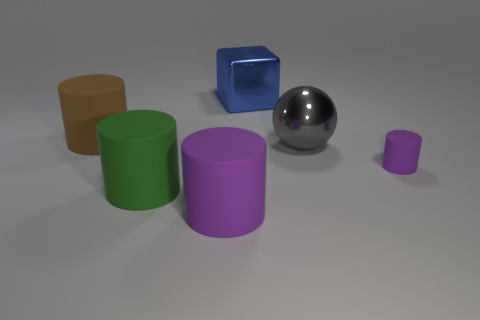Subtract all gray cylinders. Subtract all green blocks. How many cylinders are left? 4 Add 4 small purple cubes. How many objects exist? 10 Subtract all balls. How many objects are left? 5 Subtract all large green shiny blocks. Subtract all big blue things. How many objects are left? 5 Add 6 brown objects. How many brown objects are left? 7 Add 3 matte objects. How many matte objects exist? 7 Subtract 0 gray blocks. How many objects are left? 6 